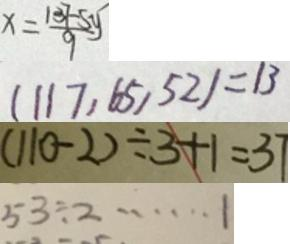<formula> <loc_0><loc_0><loc_500><loc_500>x = \frac { 1 3 7 - 5 y } { 9 } 
 ( 1 1 7 , 6 5 , 5 2 ) = 1 3 
 ( 1 1 0 - 2 ) \div 3 + 1 = 3 7 
 5 3 \div 2 \cdots 1</formula> 